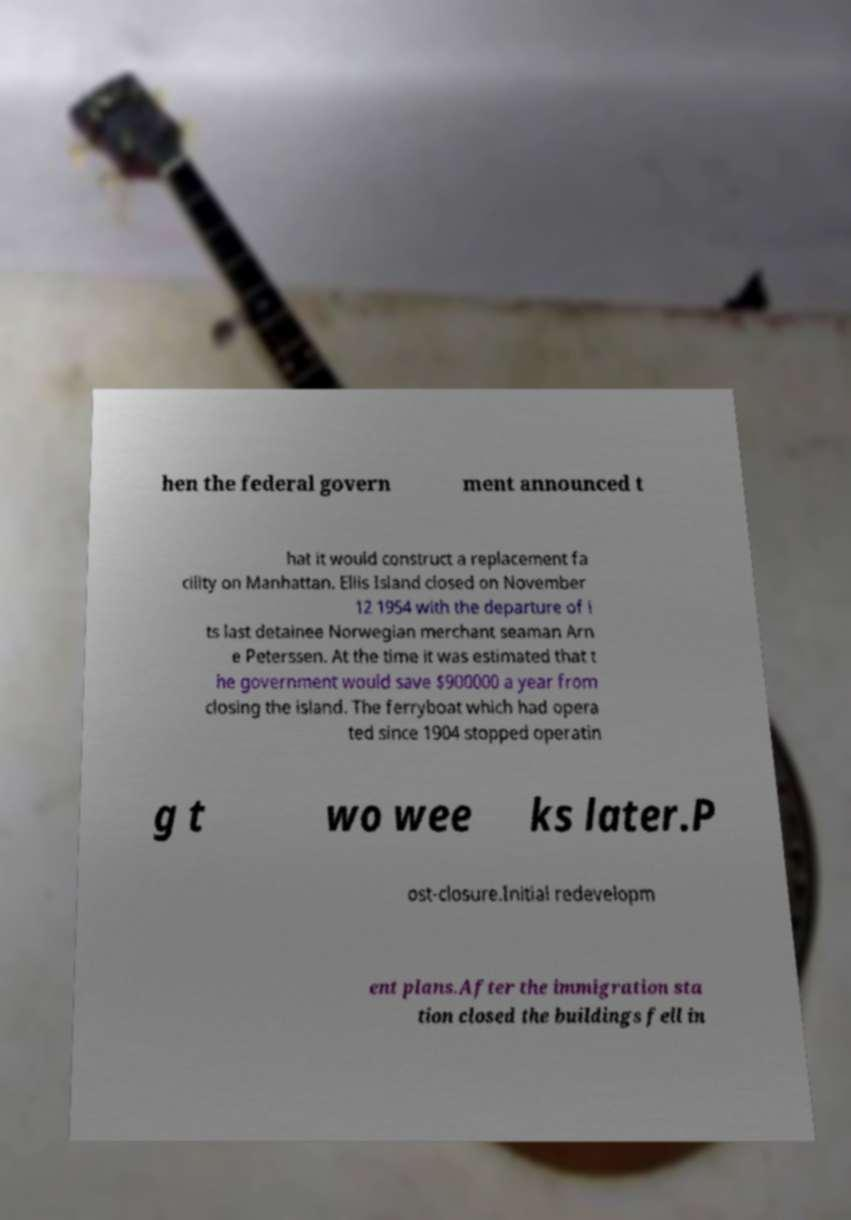Please identify and transcribe the text found in this image. hen the federal govern ment announced t hat it would construct a replacement fa cility on Manhattan. Ellis Island closed on November 12 1954 with the departure of i ts last detainee Norwegian merchant seaman Arn e Peterssen. At the time it was estimated that t he government would save $900000 a year from closing the island. The ferryboat which had opera ted since 1904 stopped operatin g t wo wee ks later.P ost-closure.Initial redevelopm ent plans.After the immigration sta tion closed the buildings fell in 